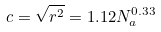<formula> <loc_0><loc_0><loc_500><loc_500>c = \sqrt { r ^ { 2 } } = 1 . 1 2 N _ { a } ^ { 0 . 3 3 }</formula> 